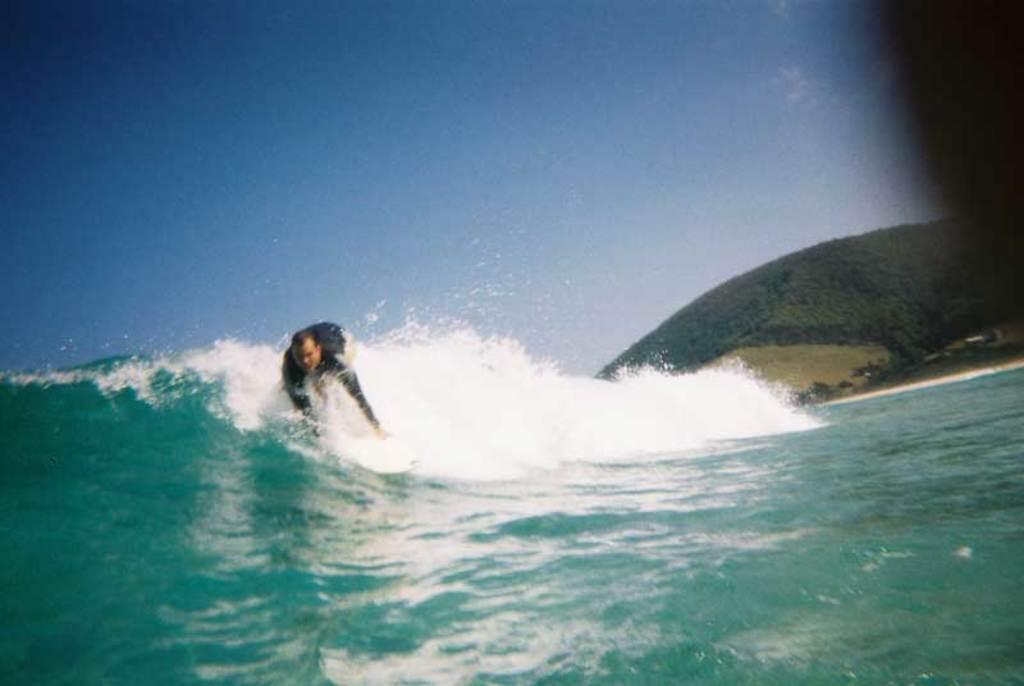Can you describe this image briefly? In this image a man is surfing on water surface. In the background there are trees, hills. The sky is clear. 